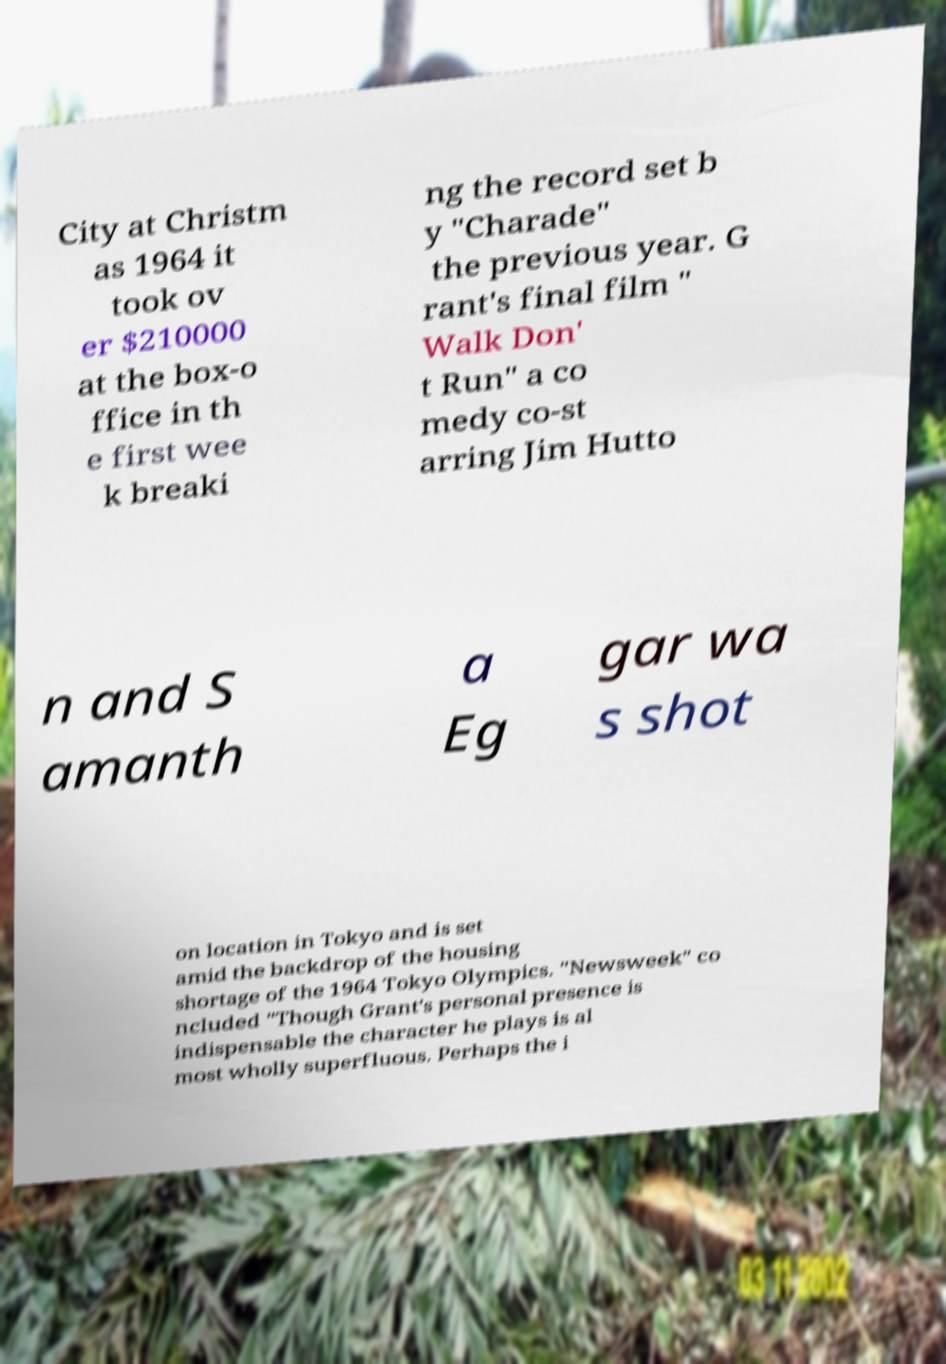For documentation purposes, I need the text within this image transcribed. Could you provide that? City at Christm as 1964 it took ov er $210000 at the box-o ffice in th e first wee k breaki ng the record set b y "Charade" the previous year. G rant's final film " Walk Don' t Run" a co medy co-st arring Jim Hutto n and S amanth a Eg gar wa s shot on location in Tokyo and is set amid the backdrop of the housing shortage of the 1964 Tokyo Olympics. "Newsweek" co ncluded "Though Grant's personal presence is indispensable the character he plays is al most wholly superfluous. Perhaps the i 